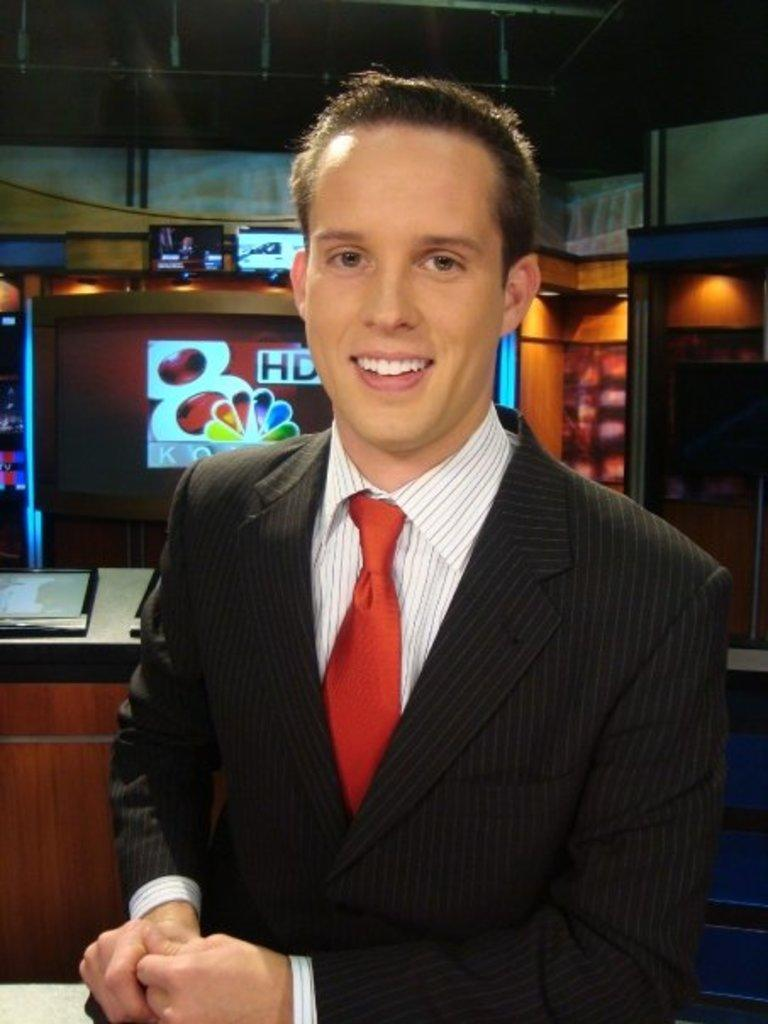Who is in the image? There is a man in the image. What is the man wearing on his upper body? The man is wearing a white shirt and a black coat. What accessory is the man wearing around his neck? The man is wearing a red tie. What can be seen in the background of the image? There is a shop in the background of the image. Reasoning: Let' Let's think step by step in order to produce the conversation. We start by identifying the main subject in the image, which is the man. Then, we describe the man's clothing, focusing on the shirt, coat, and tie. Finally, we mention the shop in the background to provide context for the setting. Absurd Question/Answer: What color is the man's eye in the image? The provided facts do not mention the color of the man's eye, so we cannot determine it from the image. How many baskets can be seen in the image? There are no baskets present in the image. What color is the man's eye in the image? The provided facts do not mention the color of the man's eye, so we cannot determine it from the image. How many baskets can be seen in the image? There are no baskets present in the image. 